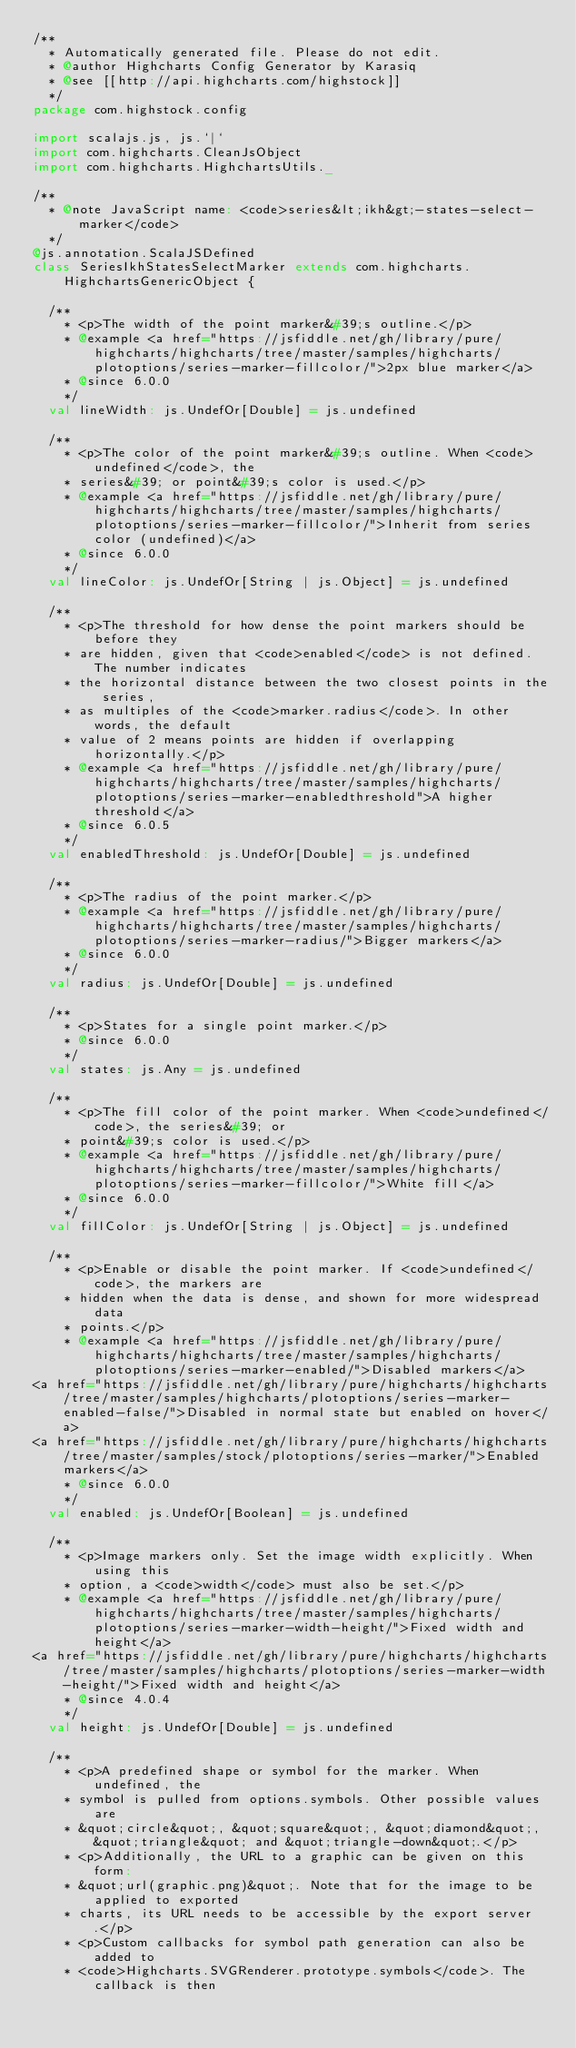<code> <loc_0><loc_0><loc_500><loc_500><_Scala_>/**
  * Automatically generated file. Please do not edit.
  * @author Highcharts Config Generator by Karasiq
  * @see [[http://api.highcharts.com/highstock]]
  */
package com.highstock.config

import scalajs.js, js.`|`
import com.highcharts.CleanJsObject
import com.highcharts.HighchartsUtils._

/**
  * @note JavaScript name: <code>series&lt;ikh&gt;-states-select-marker</code>
  */
@js.annotation.ScalaJSDefined
class SeriesIkhStatesSelectMarker extends com.highcharts.HighchartsGenericObject {

  /**
    * <p>The width of the point marker&#39;s outline.</p>
    * @example <a href="https://jsfiddle.net/gh/library/pure/highcharts/highcharts/tree/master/samples/highcharts/plotoptions/series-marker-fillcolor/">2px blue marker</a>
    * @since 6.0.0
    */
  val lineWidth: js.UndefOr[Double] = js.undefined

  /**
    * <p>The color of the point marker&#39;s outline. When <code>undefined</code>, the
    * series&#39; or point&#39;s color is used.</p>
    * @example <a href="https://jsfiddle.net/gh/library/pure/highcharts/highcharts/tree/master/samples/highcharts/plotoptions/series-marker-fillcolor/">Inherit from series color (undefined)</a>
    * @since 6.0.0
    */
  val lineColor: js.UndefOr[String | js.Object] = js.undefined

  /**
    * <p>The threshold for how dense the point markers should be before they
    * are hidden, given that <code>enabled</code> is not defined. The number indicates
    * the horizontal distance between the two closest points in the series,
    * as multiples of the <code>marker.radius</code>. In other words, the default
    * value of 2 means points are hidden if overlapping horizontally.</p>
    * @example <a href="https://jsfiddle.net/gh/library/pure/highcharts/highcharts/tree/master/samples/highcharts/plotoptions/series-marker-enabledthreshold">A higher threshold</a>
    * @since 6.0.5
    */
  val enabledThreshold: js.UndefOr[Double] = js.undefined

  /**
    * <p>The radius of the point marker.</p>
    * @example <a href="https://jsfiddle.net/gh/library/pure/highcharts/highcharts/tree/master/samples/highcharts/plotoptions/series-marker-radius/">Bigger markers</a>
    * @since 6.0.0
    */
  val radius: js.UndefOr[Double] = js.undefined

  /**
    * <p>States for a single point marker.</p>
    * @since 6.0.0
    */
  val states: js.Any = js.undefined

  /**
    * <p>The fill color of the point marker. When <code>undefined</code>, the series&#39; or
    * point&#39;s color is used.</p>
    * @example <a href="https://jsfiddle.net/gh/library/pure/highcharts/highcharts/tree/master/samples/highcharts/plotoptions/series-marker-fillcolor/">White fill</a>
    * @since 6.0.0
    */
  val fillColor: js.UndefOr[String | js.Object] = js.undefined

  /**
    * <p>Enable or disable the point marker. If <code>undefined</code>, the markers are
    * hidden when the data is dense, and shown for more widespread data
    * points.</p>
    * @example <a href="https://jsfiddle.net/gh/library/pure/highcharts/highcharts/tree/master/samples/highcharts/plotoptions/series-marker-enabled/">Disabled markers</a>
<a href="https://jsfiddle.net/gh/library/pure/highcharts/highcharts/tree/master/samples/highcharts/plotoptions/series-marker-enabled-false/">Disabled in normal state but enabled on hover</a>
<a href="https://jsfiddle.net/gh/library/pure/highcharts/highcharts/tree/master/samples/stock/plotoptions/series-marker/">Enabled markers</a>
    * @since 6.0.0
    */
  val enabled: js.UndefOr[Boolean] = js.undefined

  /**
    * <p>Image markers only. Set the image width explicitly. When using this
    * option, a <code>width</code> must also be set.</p>
    * @example <a href="https://jsfiddle.net/gh/library/pure/highcharts/highcharts/tree/master/samples/highcharts/plotoptions/series-marker-width-height/">Fixed width and height</a>
<a href="https://jsfiddle.net/gh/library/pure/highcharts/highcharts/tree/master/samples/highcharts/plotoptions/series-marker-width-height/">Fixed width and height</a>
    * @since 4.0.4
    */
  val height: js.UndefOr[Double] = js.undefined

  /**
    * <p>A predefined shape or symbol for the marker. When undefined, the
    * symbol is pulled from options.symbols. Other possible values are
    * &quot;circle&quot;, &quot;square&quot;, &quot;diamond&quot;, &quot;triangle&quot; and &quot;triangle-down&quot;.</p>
    * <p>Additionally, the URL to a graphic can be given on this form:
    * &quot;url(graphic.png)&quot;. Note that for the image to be applied to exported
    * charts, its URL needs to be accessible by the export server.</p>
    * <p>Custom callbacks for symbol path generation can also be added to
    * <code>Highcharts.SVGRenderer.prototype.symbols</code>. The callback is then</code> 